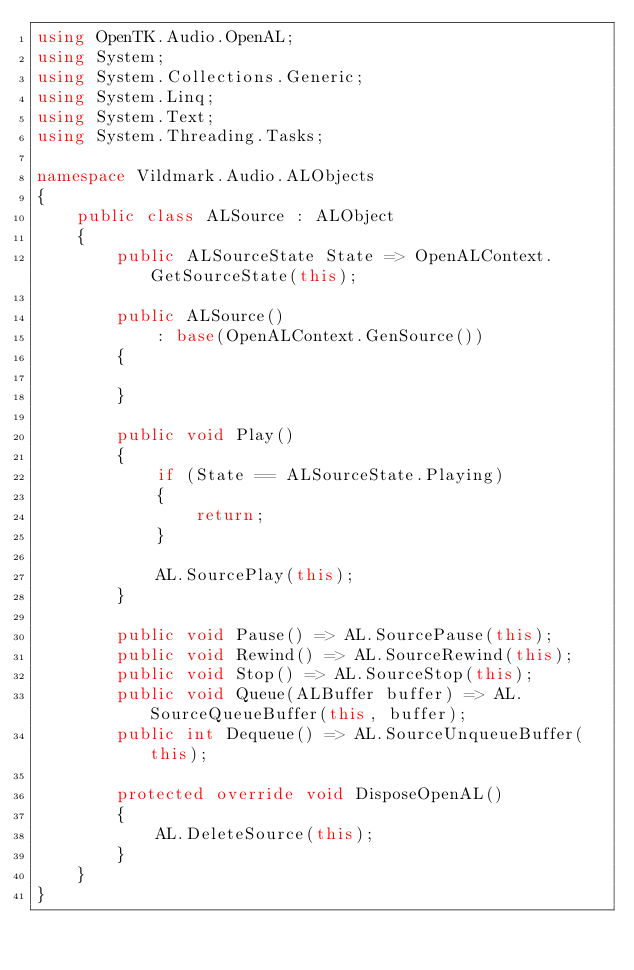Convert code to text. <code><loc_0><loc_0><loc_500><loc_500><_C#_>using OpenTK.Audio.OpenAL;
using System;
using System.Collections.Generic;
using System.Linq;
using System.Text;
using System.Threading.Tasks;

namespace Vildmark.Audio.ALObjects
{
    public class ALSource : ALObject
    {
        public ALSourceState State => OpenALContext.GetSourceState(this);

        public ALSource()
            : base(OpenALContext.GenSource())
        {

        }

        public void Play()
        {
            if (State == ALSourceState.Playing)
            {
                return;
            }

            AL.SourcePlay(this);
        }

        public void Pause() => AL.SourcePause(this);
        public void Rewind() => AL.SourceRewind(this);
        public void Stop() => AL.SourceStop(this);
        public void Queue(ALBuffer buffer) => AL.SourceQueueBuffer(this, buffer);
        public int Dequeue() => AL.SourceUnqueueBuffer(this);

        protected override void DisposeOpenAL()
        {
            AL.DeleteSource(this);
        }
    }
}
</code> 